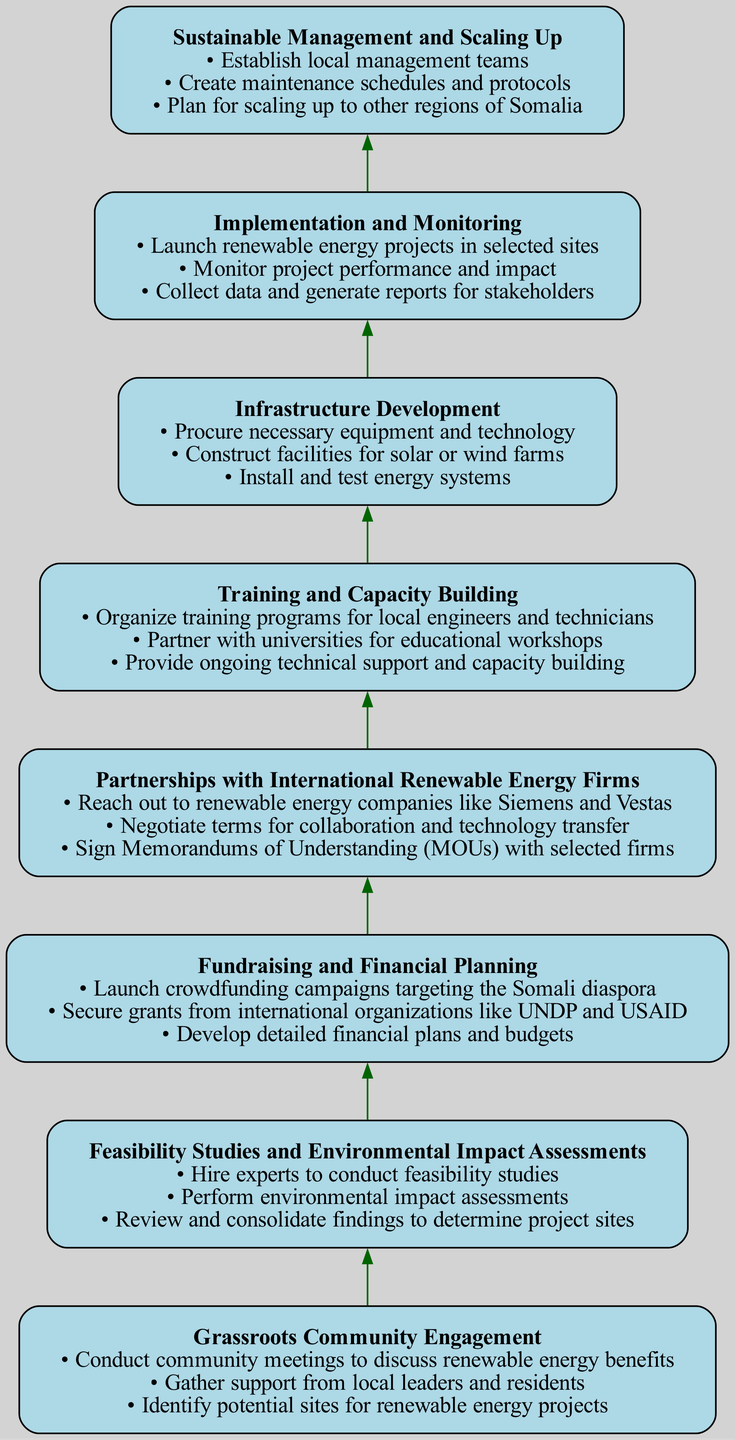What is the topmost node in the diagram? The topmost node in the diagram represents the final stage of the process, which is "Sustainable Management and Scaling Up". This can be identified by looking at the highest point in the flow chart.
Answer: Sustainable Management and Scaling Up How many tasks are listed under "Fundraising and Financial Planning"? The node representing "Fundraising and Financial Planning" includes three tasks as indicated in the diagram. This can be confirmed by counting the bullet points listed under that node.
Answer: 3 Which node directly precedes "Infrastructure Development"? The node that directly precedes "Infrastructure Development" is "Partnerships with International Renewable Energy Firms". This relationship can be inferred by looking at the flow from the bottom to the top of the diagram where connections are shown.
Answer: Partnerships with International Renewable Energy Firms What is the main focus of the "Implementation and Monitoring" stage? The focus of the "Implementation and Monitoring" stage includes launching the renewable energy projects, which indicates the primary actions taken during this phase as described in the tasks. This can be derived from the content of that node.
Answer: Launch renewable energy projects How is "Training and Capacity Building" related to "Grassroots Community Engagement"? "Training and Capacity Building" is a step that follows "Grassroots Community Engagement". It highlights the importance of community involvement as a foundation to build skills, which shows the flow of actions necessary to establish renewable energy initiatives.
Answer: It follows as a necessary step What are the three key tasks in "Feasibility Studies and Environmental Impact Assessments"? The three tasks include hiring experts, performing environmental assessments, and consolidating findings. This can be determined by closely examining the bullet points listed beneath the "Feasibility Studies and Environmental Impact Assessments" node.
Answer: Hire experts, perform environmental assessments, consolidate findings Which stage involves securing collaboration with international firms? The stage that involves securing collaboration with international firms is "Partnerships with International Renewable Energy Firms". This can be identified as direct outreach and negotiation tasks are specified under this node.
Answer: Partnerships with International Renewable Energy Firms What step comes after "Infrastructure Development"? The step that comes after "Infrastructure Development" is "Implementation and Monitoring". This can be determined by observing the flow of the diagram where each box leads to the next in the upward direction.
Answer: Implementation and Monitoring 